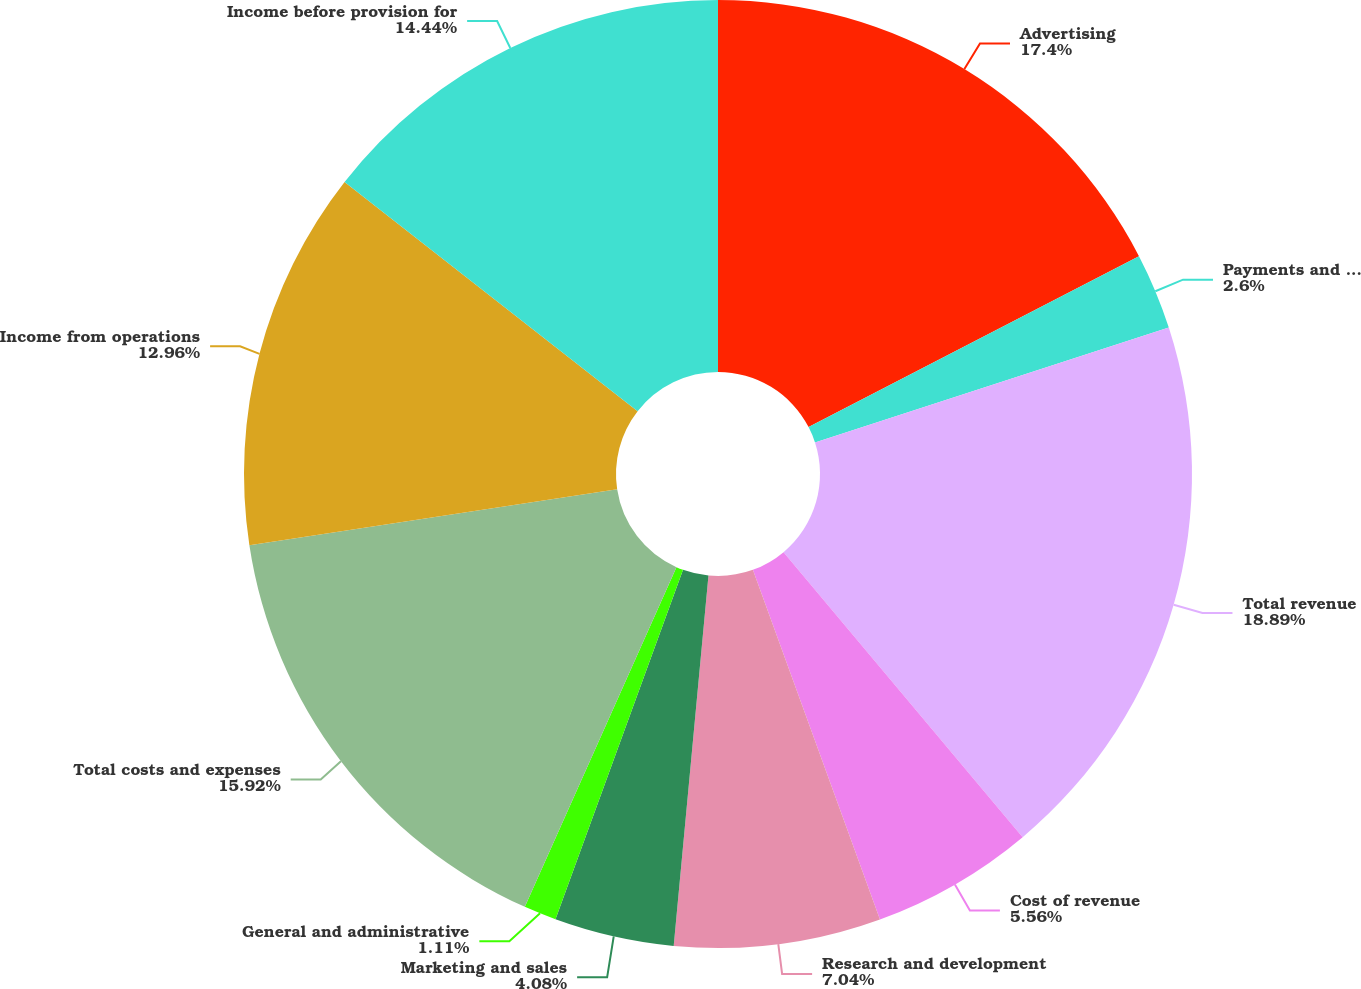<chart> <loc_0><loc_0><loc_500><loc_500><pie_chart><fcel>Advertising<fcel>Payments and other fees<fcel>Total revenue<fcel>Cost of revenue<fcel>Research and development<fcel>Marketing and sales<fcel>General and administrative<fcel>Total costs and expenses<fcel>Income from operations<fcel>Income before provision for<nl><fcel>17.4%<fcel>2.6%<fcel>18.89%<fcel>5.56%<fcel>7.04%<fcel>4.08%<fcel>1.11%<fcel>15.92%<fcel>12.96%<fcel>14.44%<nl></chart> 